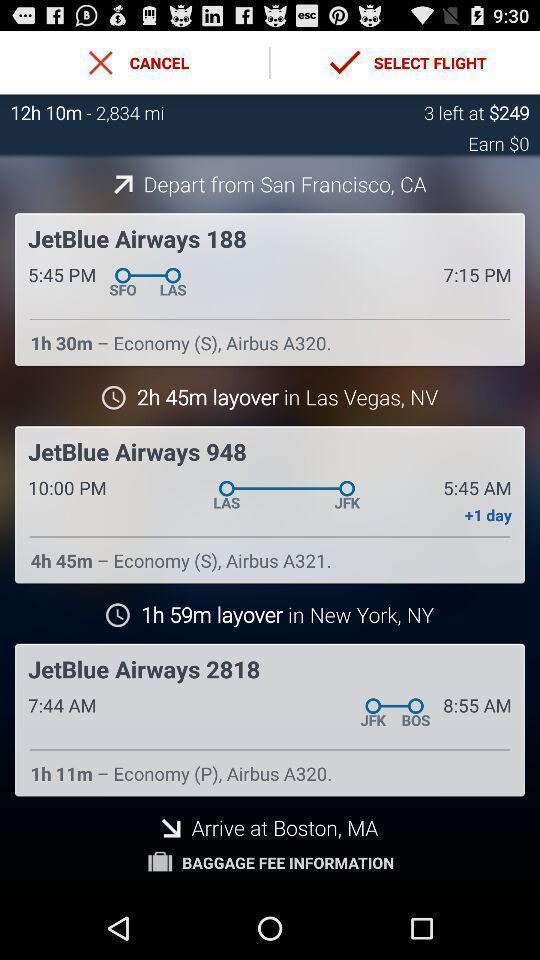Tell me what you see in this picture. Page displaying the flight location with timings. 